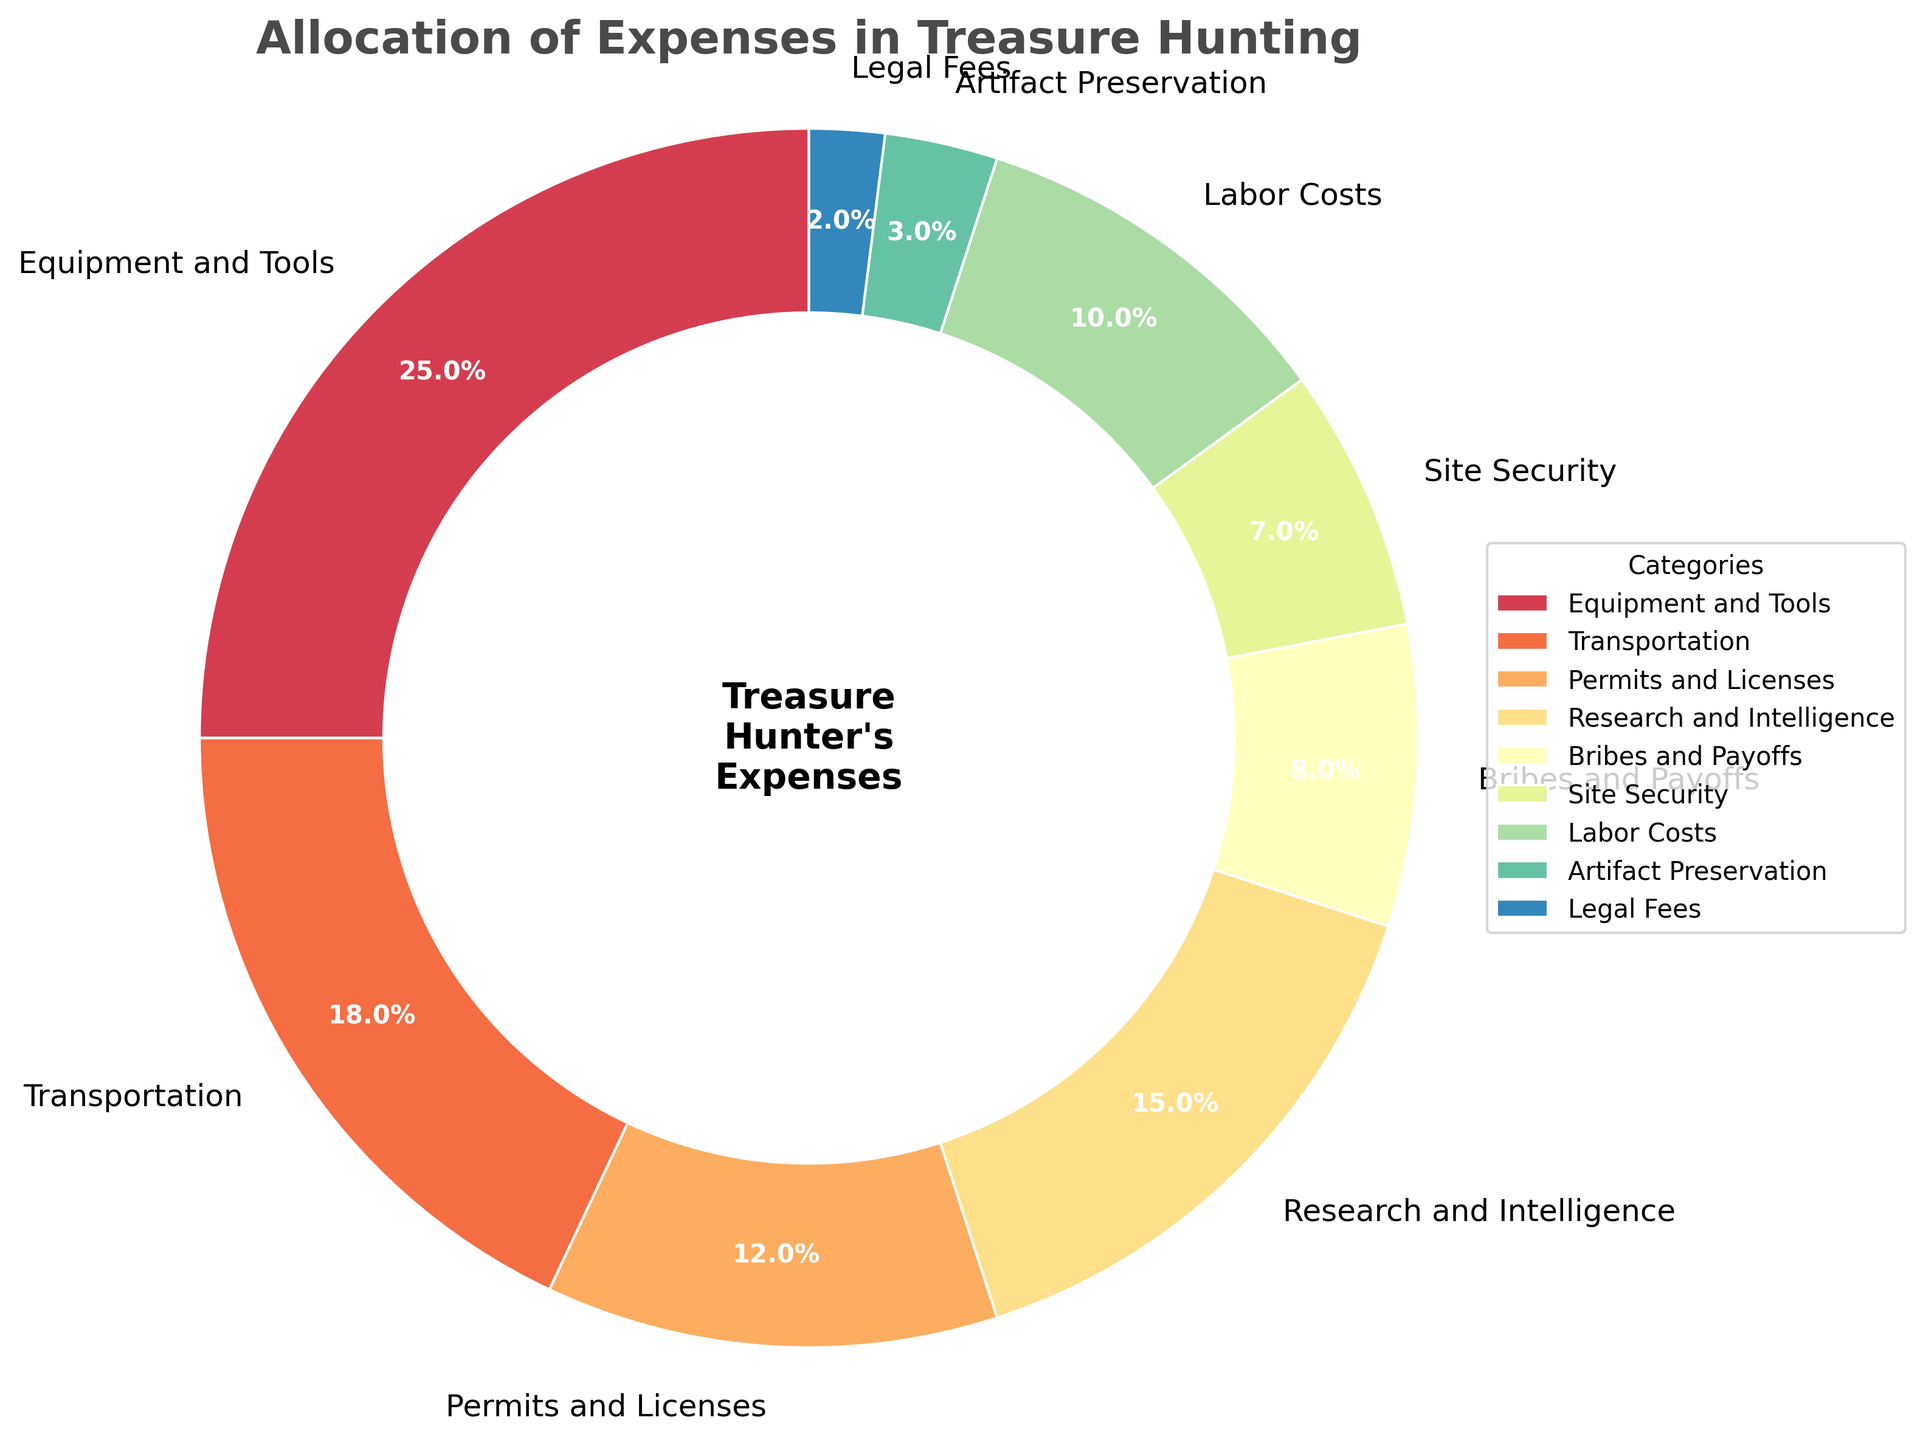What's the largest expense category in the treasure hunting operation? The figure shows "Equipment and Tools" taking up the largest portion of the pie at 25%. By comparing the sizes of the slices, we identify the one with the highest percentage.
Answer: Equipment and Tools What's the combined percentage of 'Permits and Licenses' and 'Bribes and Payoffs'? Identify the percentages of 'Permits and Licenses' (12%) and 'Bribes and Payoffs' (8%) from the pie chart. Add them together: 12% + 8% = 20%.
Answer: 20% Is the expense on 'Research and Intelligence' greater than 'Labor Costs'? Locate 'Research and Intelligence' (15%) and 'Labor Costs' (10%) on the pie chart. Compare the percentages; 15% is greater than 10%.
Answer: Yes Which expense category is represented with the smallest slice in the pie chart? Observe the pie chart and identify the slice with the smallest percentage value which is 2%. The label of that slice is 'Legal Fees'.
Answer: Legal Fees What is the difference between the 'Transportation' and 'Site Security' expenses? Find the percentages for 'Transportation' (18%) and 'Site Security' (7%). Subtract the latter from the former: 18% - 7% = 11%.
Answer: 11% Compare 'Artifact Preservation' and 'Legal Fees'. Which one has a higher expense, and by how much? Identify 'Artifact Preservation' (3%) and 'Legal Fees' (2%). Subtract 2% from 3% giving 1%. 'Artifact Preservation' is higher by 1%.
Answer: Artifact Preservation is higher by 1% What is the average expense percentage of 'Transportation', 'Labor Costs', and 'Artifact Preservation'? Identify their percentages: 'Transportation' (18%), 'Labor Costs' (10%), 'Artifact Preservation' (3%). Sum these values and divide by the number of categories: (18 + 10 + 3) / 3 = 31 / 3 = 10.33%.
Answer: 10.33% What is the total percentage of all expenses except 'Equipment and Tools'? Sum the percentages of all categories except 'Equipment and Tools': 18 + 12 + 15 + 8 + 7 + 10 + 3 + 2 = 75%.
Answer: 75% Does any category have exactly half the expense percentage of 'Transportation'? Half of 'Transportation' (18%) is 9%. No category has an exact 9% expense on the pie chart.
Answer: No Are the combined expenses of 'Site Security' and 'Legal Fees' less than 'Labor Costs'? Combine 'Site Security' (7%) and 'Legal Fees' (2%) to get 7% + 2% = 9%. Compare this with 'Labor Costs' (10%); 9% is indeed less than 10%.
Answer: Yes 